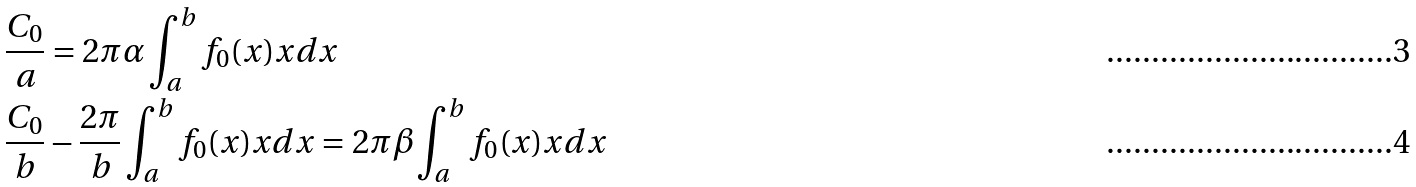<formula> <loc_0><loc_0><loc_500><loc_500>& \frac { C _ { 0 } } { a } = 2 \pi \alpha \int _ { a } ^ { b } f _ { 0 } ( x ) x d x \\ & \frac { C _ { 0 } } { b } - \frac { 2 \pi } { b } \int _ { a } ^ { b } f _ { 0 } ( x ) x d x = 2 \pi \beta \int _ { a } ^ { b } f _ { 0 } ( x ) x d x</formula> 